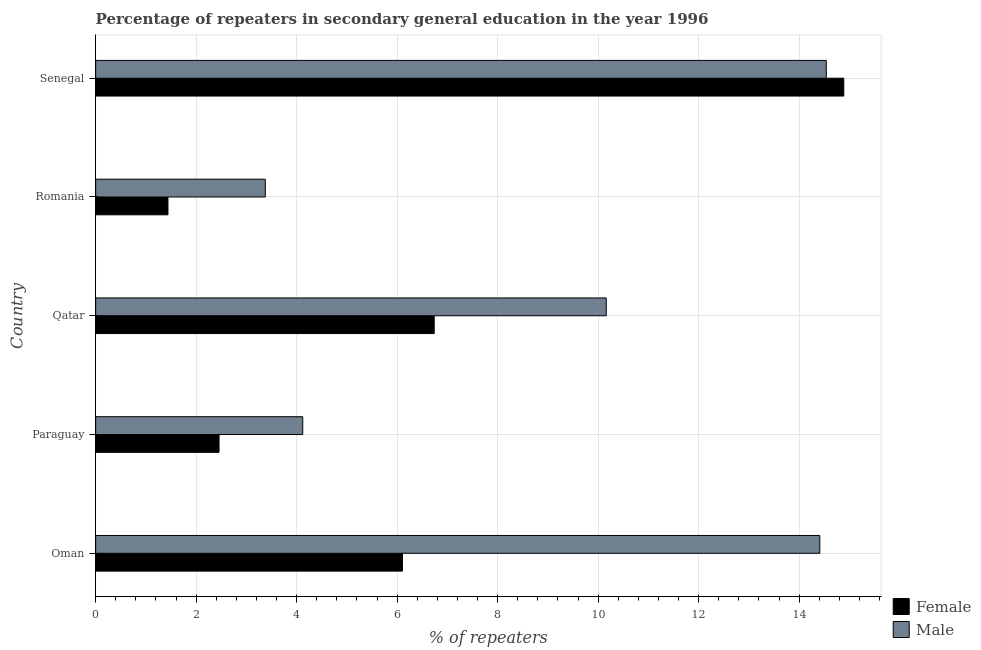How many different coloured bars are there?
Provide a short and direct response. 2. How many groups of bars are there?
Offer a terse response. 5. Are the number of bars per tick equal to the number of legend labels?
Your answer should be very brief. Yes. How many bars are there on the 5th tick from the bottom?
Ensure brevity in your answer.  2. What is the label of the 3rd group of bars from the top?
Keep it short and to the point. Qatar. What is the percentage of male repeaters in Oman?
Offer a terse response. 14.41. Across all countries, what is the maximum percentage of male repeaters?
Provide a succinct answer. 14.54. Across all countries, what is the minimum percentage of male repeaters?
Offer a terse response. 3.38. In which country was the percentage of female repeaters maximum?
Provide a succinct answer. Senegal. In which country was the percentage of male repeaters minimum?
Offer a very short reply. Romania. What is the total percentage of male repeaters in the graph?
Your answer should be compact. 46.61. What is the difference between the percentage of male repeaters in Oman and that in Senegal?
Your answer should be compact. -0.13. What is the difference between the percentage of male repeaters in Paraguay and the percentage of female repeaters in Oman?
Your answer should be compact. -1.99. What is the average percentage of male repeaters per country?
Your answer should be compact. 9.32. What is the difference between the percentage of female repeaters and percentage of male repeaters in Romania?
Give a very brief answer. -1.94. What is the ratio of the percentage of male repeaters in Paraguay to that in Romania?
Offer a terse response. 1.22. Is the percentage of female repeaters in Paraguay less than that in Romania?
Make the answer very short. No. What is the difference between the highest and the second highest percentage of female repeaters?
Your answer should be very brief. 8.15. What is the difference between the highest and the lowest percentage of male repeaters?
Provide a succinct answer. 11.17. In how many countries, is the percentage of male repeaters greater than the average percentage of male repeaters taken over all countries?
Your response must be concise. 3. Is the sum of the percentage of male repeaters in Paraguay and Senegal greater than the maximum percentage of female repeaters across all countries?
Give a very brief answer. Yes. What does the 1st bar from the top in Senegal represents?
Provide a succinct answer. Male. How many bars are there?
Provide a short and direct response. 10. How many countries are there in the graph?
Offer a terse response. 5. Are the values on the major ticks of X-axis written in scientific E-notation?
Keep it short and to the point. No. Does the graph contain grids?
Offer a very short reply. Yes. How many legend labels are there?
Offer a very short reply. 2. What is the title of the graph?
Keep it short and to the point. Percentage of repeaters in secondary general education in the year 1996. Does "Net savings(excluding particulate emission damage)" appear as one of the legend labels in the graph?
Ensure brevity in your answer.  No. What is the label or title of the X-axis?
Your response must be concise. % of repeaters. What is the label or title of the Y-axis?
Your answer should be very brief. Country. What is the % of repeaters in Female in Oman?
Your response must be concise. 6.11. What is the % of repeaters in Male in Oman?
Your answer should be compact. 14.41. What is the % of repeaters of Female in Paraguay?
Your answer should be compact. 2.46. What is the % of repeaters of Male in Paraguay?
Make the answer very short. 4.12. What is the % of repeaters of Female in Qatar?
Your answer should be very brief. 6.74. What is the % of repeaters in Male in Qatar?
Provide a short and direct response. 10.16. What is the % of repeaters of Female in Romania?
Make the answer very short. 1.44. What is the % of repeaters of Male in Romania?
Your answer should be very brief. 3.38. What is the % of repeaters of Female in Senegal?
Offer a very short reply. 14.89. What is the % of repeaters in Male in Senegal?
Give a very brief answer. 14.54. Across all countries, what is the maximum % of repeaters of Female?
Provide a short and direct response. 14.89. Across all countries, what is the maximum % of repeaters of Male?
Make the answer very short. 14.54. Across all countries, what is the minimum % of repeaters of Female?
Provide a short and direct response. 1.44. Across all countries, what is the minimum % of repeaters in Male?
Offer a terse response. 3.38. What is the total % of repeaters in Female in the graph?
Offer a very short reply. 31.63. What is the total % of repeaters in Male in the graph?
Provide a short and direct response. 46.61. What is the difference between the % of repeaters of Female in Oman and that in Paraguay?
Offer a terse response. 3.65. What is the difference between the % of repeaters of Male in Oman and that in Paraguay?
Your answer should be compact. 10.29. What is the difference between the % of repeaters in Female in Oman and that in Qatar?
Ensure brevity in your answer.  -0.63. What is the difference between the % of repeaters of Male in Oman and that in Qatar?
Give a very brief answer. 4.25. What is the difference between the % of repeaters of Female in Oman and that in Romania?
Offer a very short reply. 4.67. What is the difference between the % of repeaters of Male in Oman and that in Romania?
Your answer should be compact. 11.04. What is the difference between the % of repeaters of Female in Oman and that in Senegal?
Offer a terse response. -8.78. What is the difference between the % of repeaters of Male in Oman and that in Senegal?
Provide a short and direct response. -0.13. What is the difference between the % of repeaters in Female in Paraguay and that in Qatar?
Offer a terse response. -4.28. What is the difference between the % of repeaters in Male in Paraguay and that in Qatar?
Make the answer very short. -6.04. What is the difference between the % of repeaters of Female in Paraguay and that in Romania?
Provide a short and direct response. 1.02. What is the difference between the % of repeaters in Male in Paraguay and that in Romania?
Give a very brief answer. 0.75. What is the difference between the % of repeaters in Female in Paraguay and that in Senegal?
Offer a very short reply. -12.43. What is the difference between the % of repeaters in Male in Paraguay and that in Senegal?
Offer a terse response. -10.42. What is the difference between the % of repeaters of Female in Qatar and that in Romania?
Offer a terse response. 5.3. What is the difference between the % of repeaters of Male in Qatar and that in Romania?
Make the answer very short. 6.79. What is the difference between the % of repeaters of Female in Qatar and that in Senegal?
Your answer should be compact. -8.15. What is the difference between the % of repeaters in Male in Qatar and that in Senegal?
Offer a terse response. -4.38. What is the difference between the % of repeaters of Female in Romania and that in Senegal?
Your answer should be compact. -13.45. What is the difference between the % of repeaters in Male in Romania and that in Senegal?
Offer a terse response. -11.17. What is the difference between the % of repeaters of Female in Oman and the % of repeaters of Male in Paraguay?
Offer a terse response. 1.99. What is the difference between the % of repeaters of Female in Oman and the % of repeaters of Male in Qatar?
Ensure brevity in your answer.  -4.06. What is the difference between the % of repeaters of Female in Oman and the % of repeaters of Male in Romania?
Make the answer very short. 2.73. What is the difference between the % of repeaters in Female in Oman and the % of repeaters in Male in Senegal?
Your response must be concise. -8.43. What is the difference between the % of repeaters in Female in Paraguay and the % of repeaters in Male in Qatar?
Your answer should be compact. -7.71. What is the difference between the % of repeaters in Female in Paraguay and the % of repeaters in Male in Romania?
Provide a succinct answer. -0.92. What is the difference between the % of repeaters of Female in Paraguay and the % of repeaters of Male in Senegal?
Provide a succinct answer. -12.09. What is the difference between the % of repeaters of Female in Qatar and the % of repeaters of Male in Romania?
Provide a short and direct response. 3.36. What is the difference between the % of repeaters of Female in Qatar and the % of repeaters of Male in Senegal?
Give a very brief answer. -7.8. What is the difference between the % of repeaters of Female in Romania and the % of repeaters of Male in Senegal?
Give a very brief answer. -13.1. What is the average % of repeaters in Female per country?
Provide a short and direct response. 6.33. What is the average % of repeaters in Male per country?
Offer a terse response. 9.32. What is the difference between the % of repeaters in Female and % of repeaters in Male in Oman?
Your answer should be very brief. -8.31. What is the difference between the % of repeaters in Female and % of repeaters in Male in Paraguay?
Provide a short and direct response. -1.67. What is the difference between the % of repeaters of Female and % of repeaters of Male in Qatar?
Your answer should be very brief. -3.42. What is the difference between the % of repeaters in Female and % of repeaters in Male in Romania?
Give a very brief answer. -1.94. What is the difference between the % of repeaters of Female and % of repeaters of Male in Senegal?
Give a very brief answer. 0.35. What is the ratio of the % of repeaters in Female in Oman to that in Paraguay?
Offer a terse response. 2.49. What is the ratio of the % of repeaters in Male in Oman to that in Paraguay?
Your answer should be very brief. 3.5. What is the ratio of the % of repeaters of Female in Oman to that in Qatar?
Your answer should be compact. 0.91. What is the ratio of the % of repeaters of Male in Oman to that in Qatar?
Keep it short and to the point. 1.42. What is the ratio of the % of repeaters of Female in Oman to that in Romania?
Offer a terse response. 4.24. What is the ratio of the % of repeaters of Male in Oman to that in Romania?
Make the answer very short. 4.27. What is the ratio of the % of repeaters in Female in Oman to that in Senegal?
Offer a very short reply. 0.41. What is the ratio of the % of repeaters in Female in Paraguay to that in Qatar?
Keep it short and to the point. 0.36. What is the ratio of the % of repeaters of Male in Paraguay to that in Qatar?
Provide a succinct answer. 0.41. What is the ratio of the % of repeaters in Female in Paraguay to that in Romania?
Provide a succinct answer. 1.71. What is the ratio of the % of repeaters in Male in Paraguay to that in Romania?
Offer a terse response. 1.22. What is the ratio of the % of repeaters of Female in Paraguay to that in Senegal?
Provide a succinct answer. 0.16. What is the ratio of the % of repeaters in Male in Paraguay to that in Senegal?
Provide a succinct answer. 0.28. What is the ratio of the % of repeaters in Female in Qatar to that in Romania?
Ensure brevity in your answer.  4.68. What is the ratio of the % of repeaters of Male in Qatar to that in Romania?
Provide a succinct answer. 3.01. What is the ratio of the % of repeaters of Female in Qatar to that in Senegal?
Give a very brief answer. 0.45. What is the ratio of the % of repeaters in Male in Qatar to that in Senegal?
Give a very brief answer. 0.7. What is the ratio of the % of repeaters of Female in Romania to that in Senegal?
Offer a very short reply. 0.1. What is the ratio of the % of repeaters of Male in Romania to that in Senegal?
Your response must be concise. 0.23. What is the difference between the highest and the second highest % of repeaters of Female?
Provide a succinct answer. 8.15. What is the difference between the highest and the second highest % of repeaters of Male?
Provide a short and direct response. 0.13. What is the difference between the highest and the lowest % of repeaters of Female?
Offer a terse response. 13.45. What is the difference between the highest and the lowest % of repeaters of Male?
Your response must be concise. 11.17. 